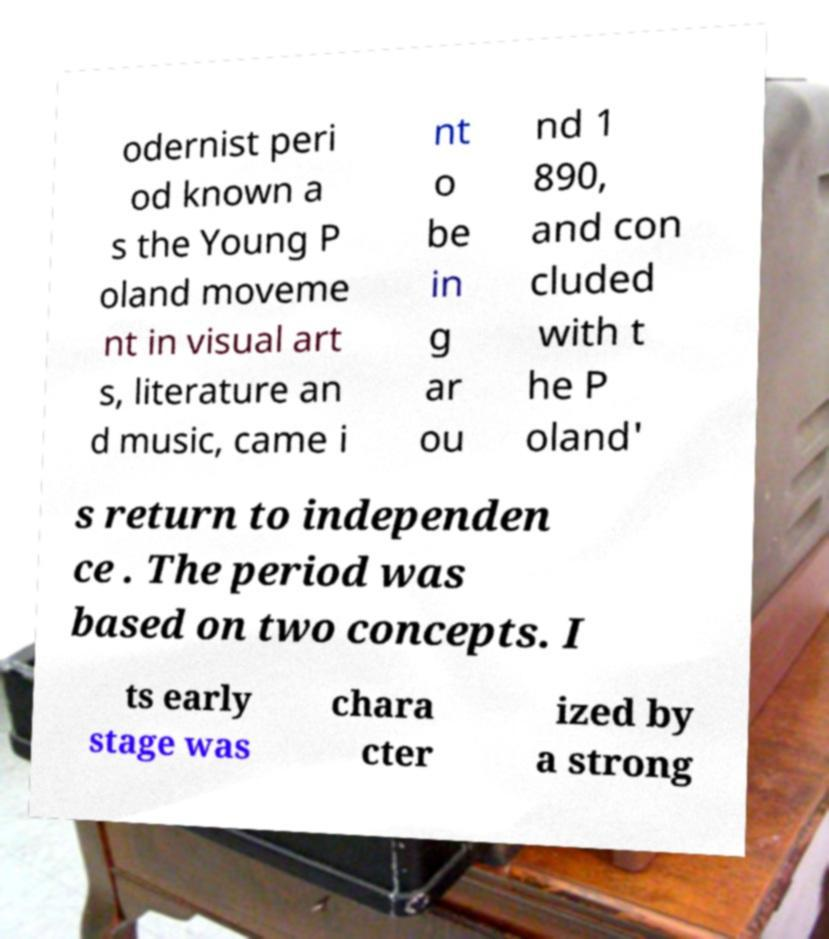For documentation purposes, I need the text within this image transcribed. Could you provide that? odernist peri od known a s the Young P oland moveme nt in visual art s, literature an d music, came i nt o be in g ar ou nd 1 890, and con cluded with t he P oland' s return to independen ce . The period was based on two concepts. I ts early stage was chara cter ized by a strong 